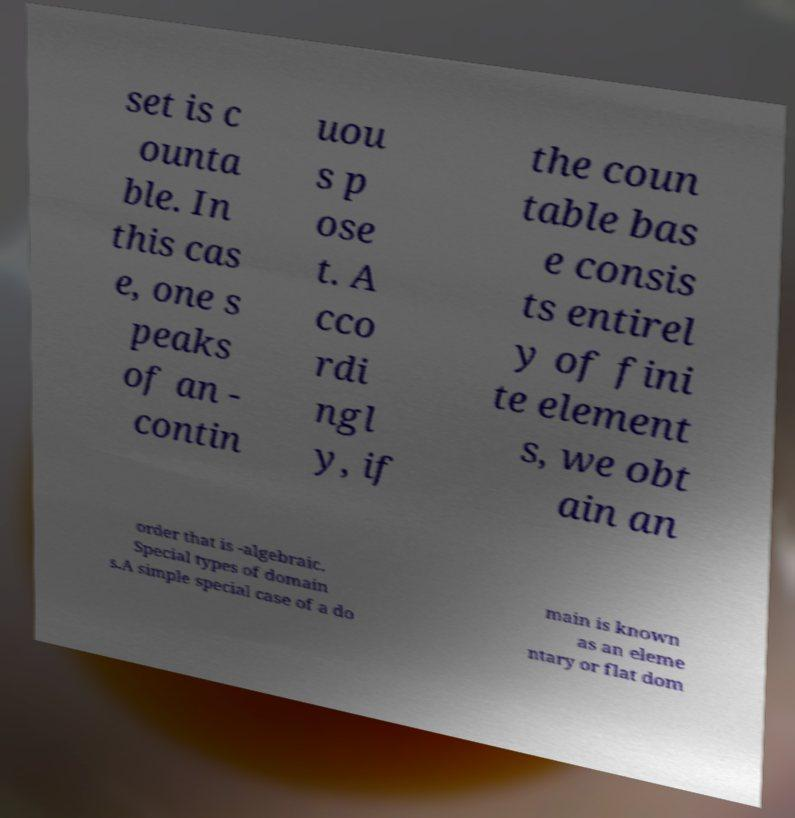Can you read and provide the text displayed in the image?This photo seems to have some interesting text. Can you extract and type it out for me? set is c ounta ble. In this cas e, one s peaks of an - contin uou s p ose t. A cco rdi ngl y, if the coun table bas e consis ts entirel y of fini te element s, we obt ain an order that is -algebraic. Special types of domain s.A simple special case of a do main is known as an eleme ntary or flat dom 